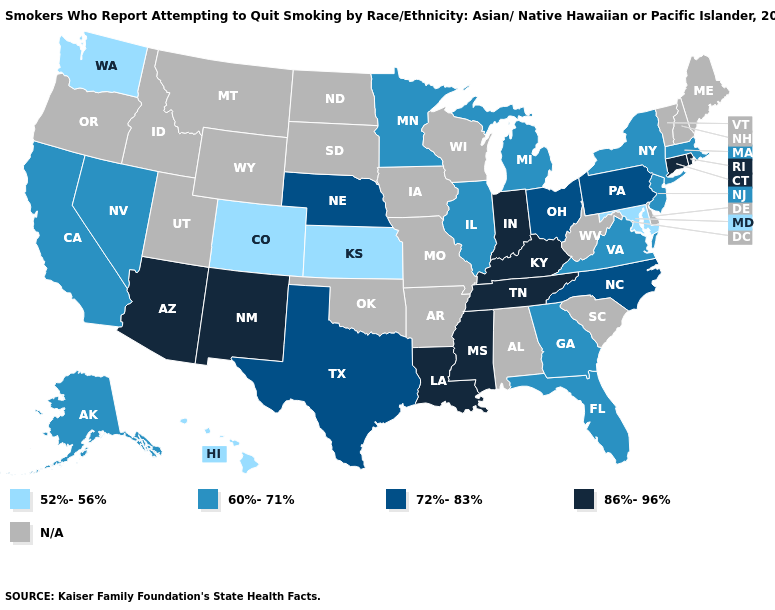What is the value of Kansas?
Give a very brief answer. 52%-56%. Which states hav the highest value in the MidWest?
Answer briefly. Indiana. Does Tennessee have the highest value in the USA?
Write a very short answer. Yes. Name the states that have a value in the range 52%-56%?
Give a very brief answer. Colorado, Hawaii, Kansas, Maryland, Washington. What is the lowest value in the USA?
Concise answer only. 52%-56%. What is the highest value in the West ?
Be succinct. 86%-96%. What is the highest value in the USA?
Write a very short answer. 86%-96%. What is the value of South Dakota?
Concise answer only. N/A. What is the value of Alabama?
Write a very short answer. N/A. Does Indiana have the highest value in the MidWest?
Quick response, please. Yes. Name the states that have a value in the range 60%-71%?
Short answer required. Alaska, California, Florida, Georgia, Illinois, Massachusetts, Michigan, Minnesota, Nevada, New Jersey, New York, Virginia. What is the highest value in the West ?
Write a very short answer. 86%-96%. What is the lowest value in the MidWest?
Be succinct. 52%-56%. 